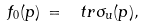Convert formula to latex. <formula><loc_0><loc_0><loc_500><loc_500>f _ { 0 } ( p ) \, = \, \ t r \sigma _ { u } ( p ) ,</formula> 